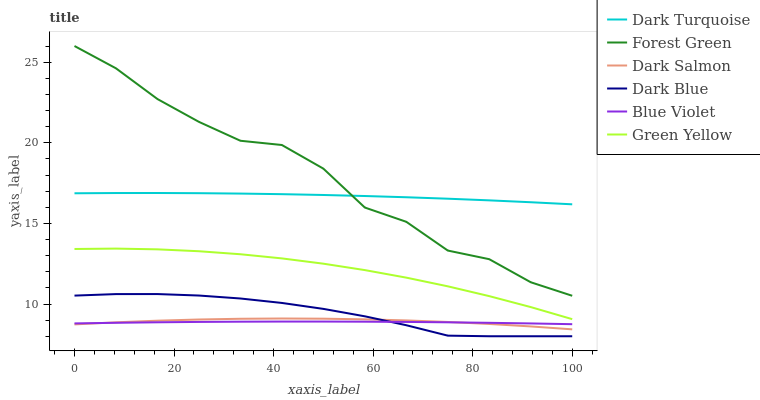Does Blue Violet have the minimum area under the curve?
Answer yes or no. Yes. Does Forest Green have the maximum area under the curve?
Answer yes or no. Yes. Does Dark Salmon have the minimum area under the curve?
Answer yes or no. No. Does Dark Salmon have the maximum area under the curve?
Answer yes or no. No. Is Blue Violet the smoothest?
Answer yes or no. Yes. Is Forest Green the roughest?
Answer yes or no. Yes. Is Dark Salmon the smoothest?
Answer yes or no. No. Is Dark Salmon the roughest?
Answer yes or no. No. Does Dark Blue have the lowest value?
Answer yes or no. Yes. Does Dark Salmon have the lowest value?
Answer yes or no. No. Does Forest Green have the highest value?
Answer yes or no. Yes. Does Dark Salmon have the highest value?
Answer yes or no. No. Is Dark Salmon less than Dark Turquoise?
Answer yes or no. Yes. Is Forest Green greater than Dark Blue?
Answer yes or no. Yes. Does Blue Violet intersect Dark Blue?
Answer yes or no. Yes. Is Blue Violet less than Dark Blue?
Answer yes or no. No. Is Blue Violet greater than Dark Blue?
Answer yes or no. No. Does Dark Salmon intersect Dark Turquoise?
Answer yes or no. No. 